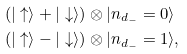Convert formula to latex. <formula><loc_0><loc_0><loc_500><loc_500>( | \uparrow \rangle + | \downarrow \rangle ) & \otimes | n _ { d _ { - } } = 0 \rangle \\ ( | \uparrow \rangle - | \downarrow \rangle ) & \otimes | n _ { d _ { - } } = 1 \rangle ,</formula> 